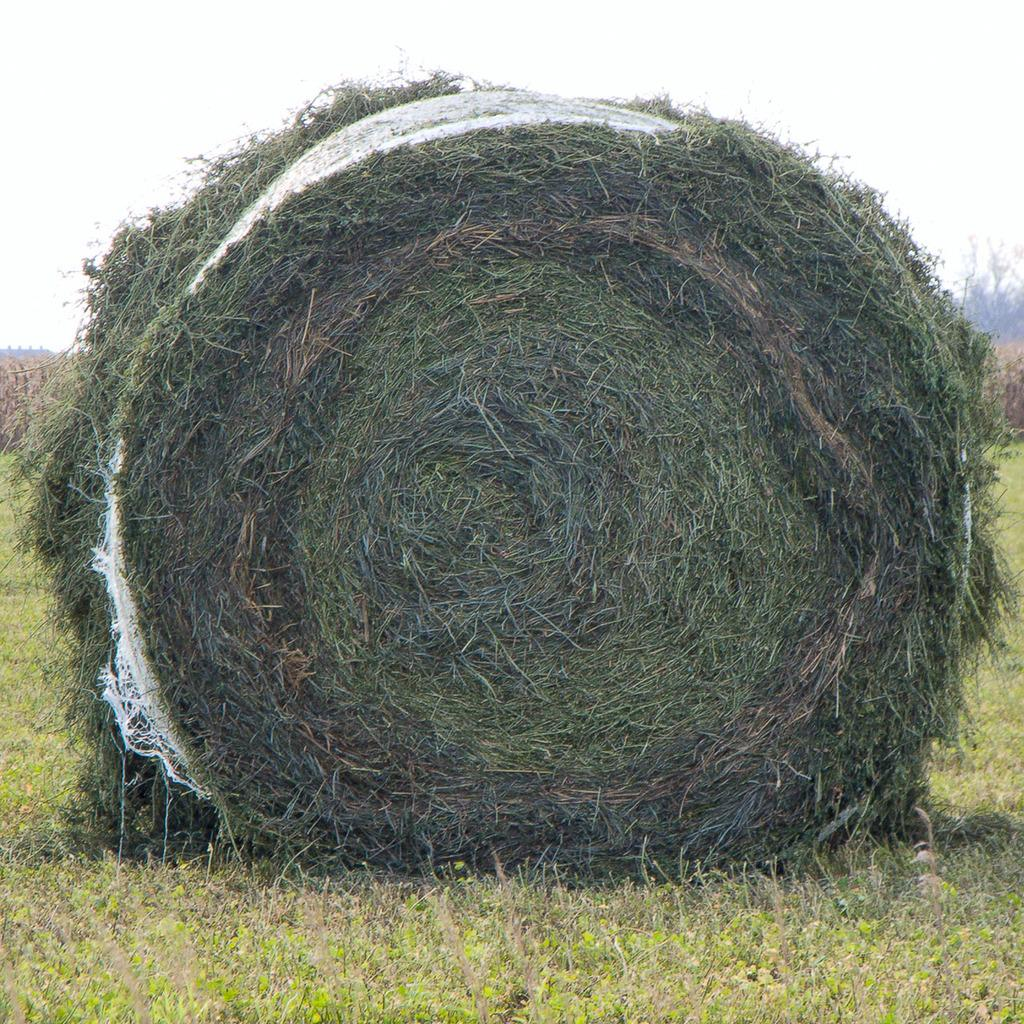What type of vegetation is present in the image? There is grass in the image. Can you describe the main feature of the grass in the image? There is a big grass bundle in the middle of the image. What can be seen in the background of the image? There are trees in the background of the image. How many dogs can be seen playing with the snake in the image? There are no dogs or snakes present in the image; it features grass and trees. 